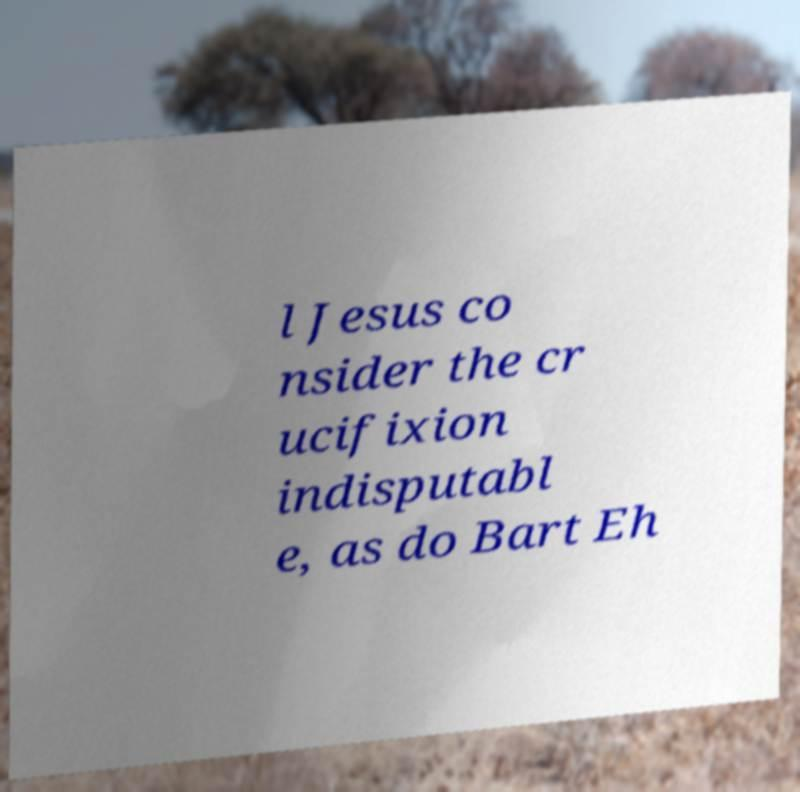Please identify and transcribe the text found in this image. l Jesus co nsider the cr ucifixion indisputabl e, as do Bart Eh 